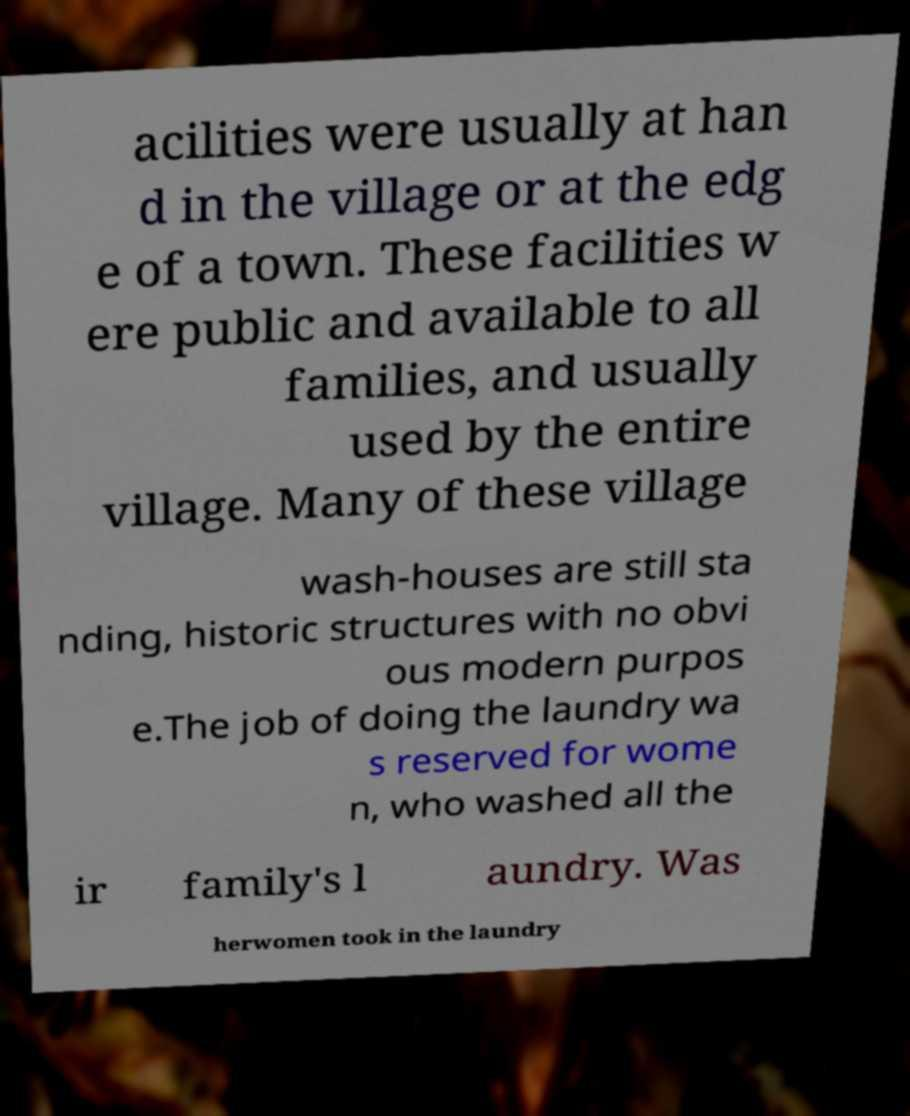Please identify and transcribe the text found in this image. acilities were usually at han d in the village or at the edg e of a town. These facilities w ere public and available to all families, and usually used by the entire village. Many of these village wash-houses are still sta nding, historic structures with no obvi ous modern purpos e.The job of doing the laundry wa s reserved for wome n, who washed all the ir family's l aundry. Was herwomen took in the laundry 